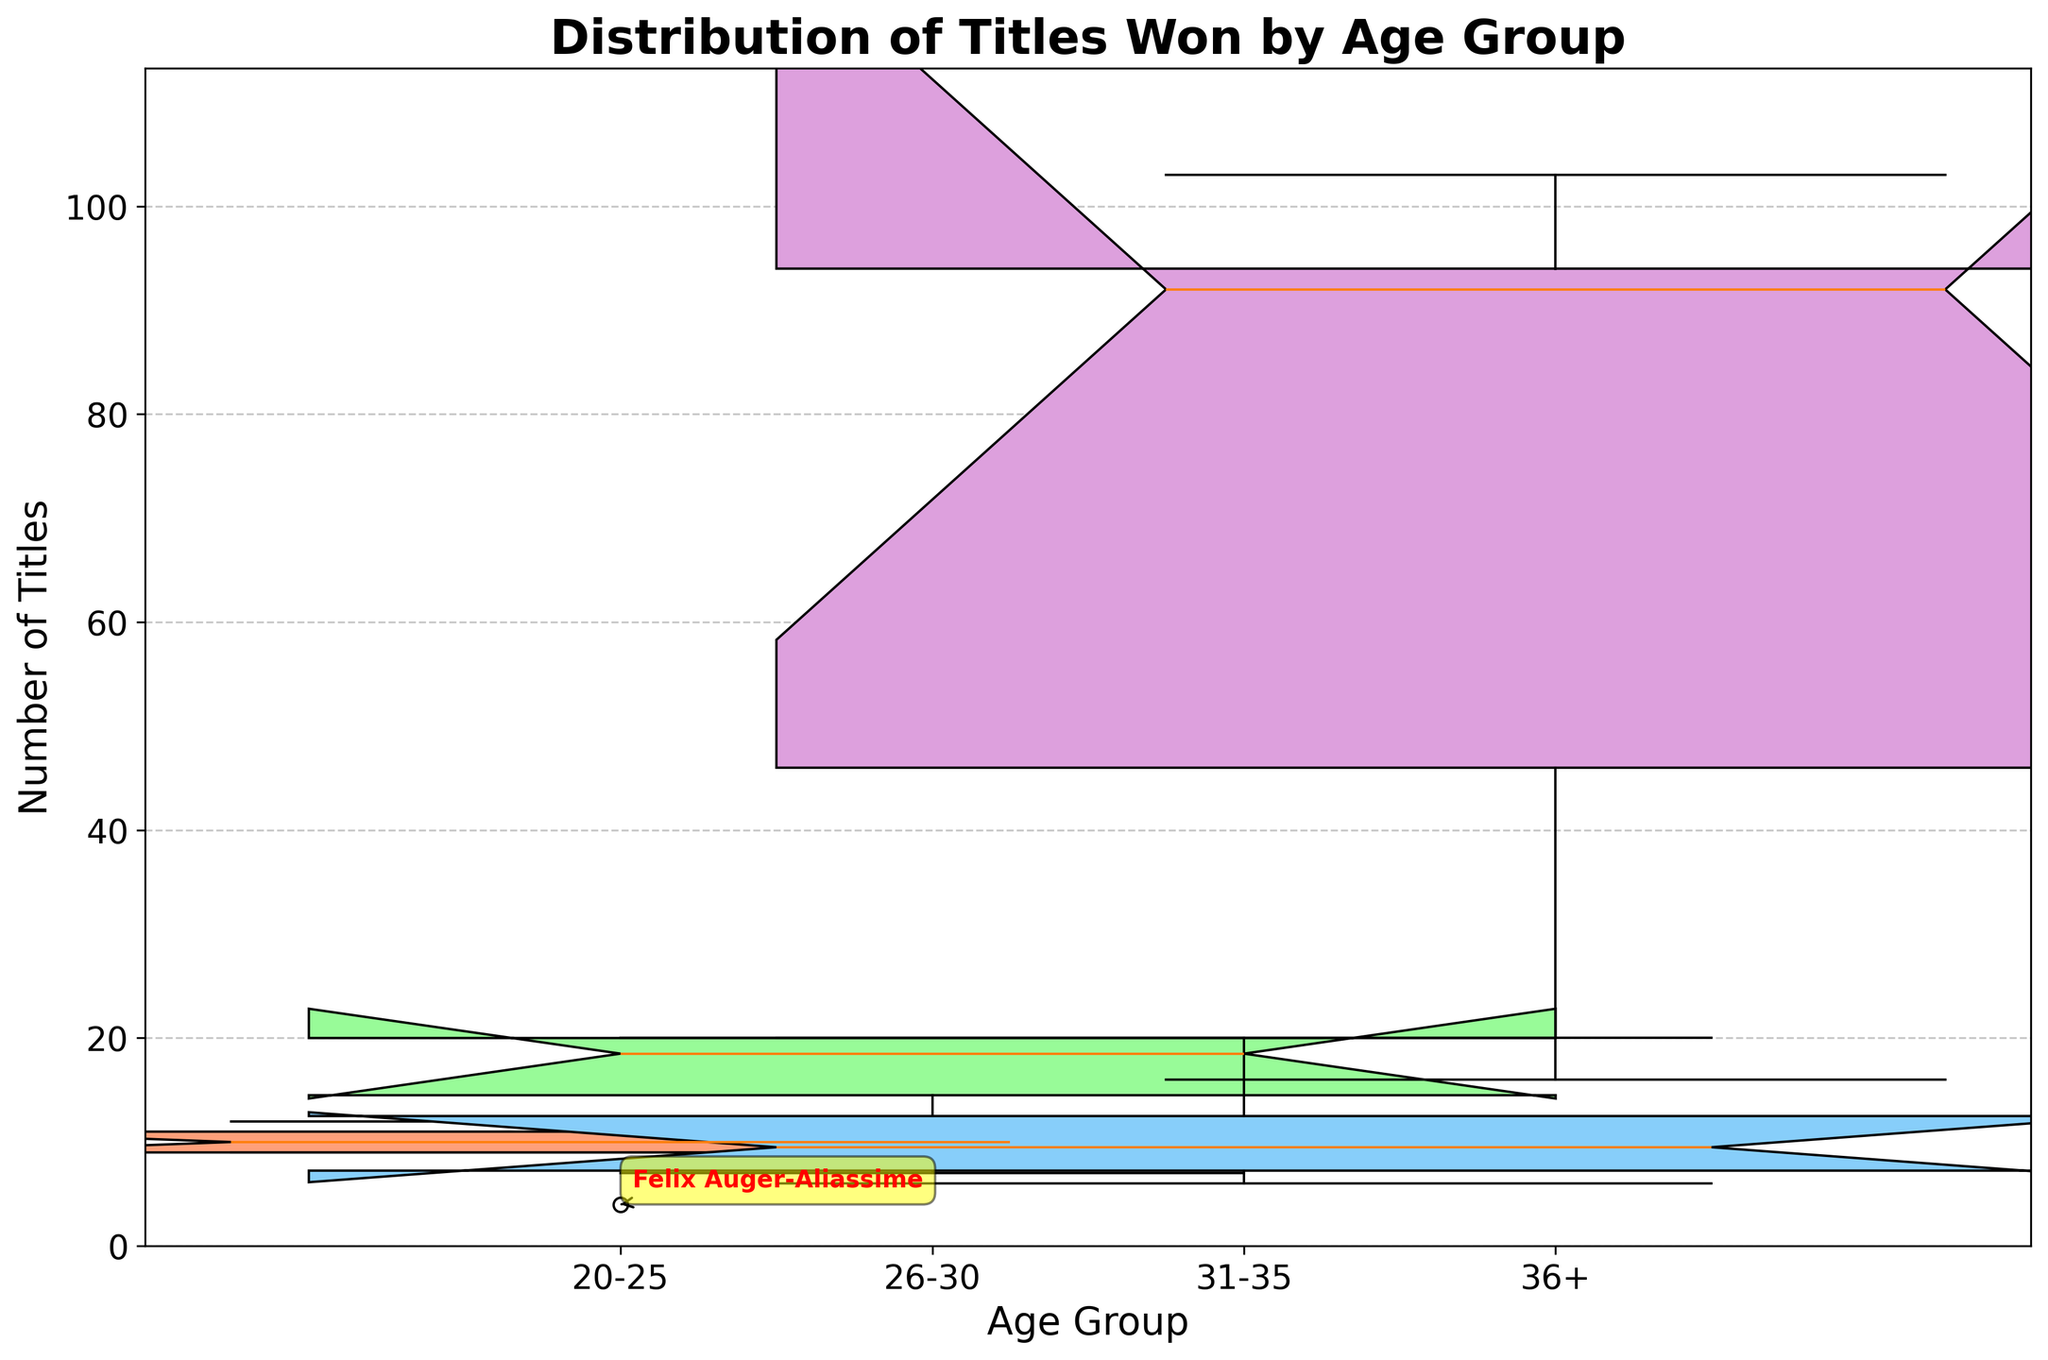How many age groups are in the plot? The x-axis of the plot shows the age groups. Counting them will give the total number of age groups.
Answer: 4 Which age group has the widest box? The width of the box represents the number of players in each age group. By comparing the widths, identify the age group with the widest box.
Answer: 20-25 What is the median number of titles in the '36+' age group? Look at the median line inside the box for the '36+' age group in the plot to get the number.
Answer: 92 Which player's number of titles is annotated as an outlier in the '26-30' age group? Examine the annotations for outliers in the '26-30' age group box. The player's name will be displayed next to the outlier point.
Answer: Nick Kyrgios What is the interquartile range (IQR) for the '31-35' age group? The IQR is the difference between the third quartile (Q3) and the first quartile (Q1) in the box plot for the '31-35' age group. Find Q1 and Q3 from the box and subtract Q1 from Q3.
Answer: 10 Which age group has the highest variance in the number of titles? Variance is a measure of how spread out the numbers are. The age group with the most spread-out box and whiskers likely has the highest variance.
Answer: 36+ Are there any age groups without outliers? Check each age group in the box plot to see if there are any outliers marked by points outside the whiskers.
Answer: Yes In which age group are the players with the fewest titles found? The fewest titles can be found by looking at the lower end of the whiskers in each age group.
Answer: 20-25 How does the number of titles of the player with the most titles compare to the median of the '31-35' age group? The player with the most titles can be identified from the annotations, and the median of the '31-35' age group can be read off of the box plot. Compare these two values.
Answer: 103 vs. 10 Which player has the highest number of titles among those aged 31-35? Check the '31-35' age group box and look at annotations or the top of the whisker/highest point in the box plot.
Answer: Andy Murray 